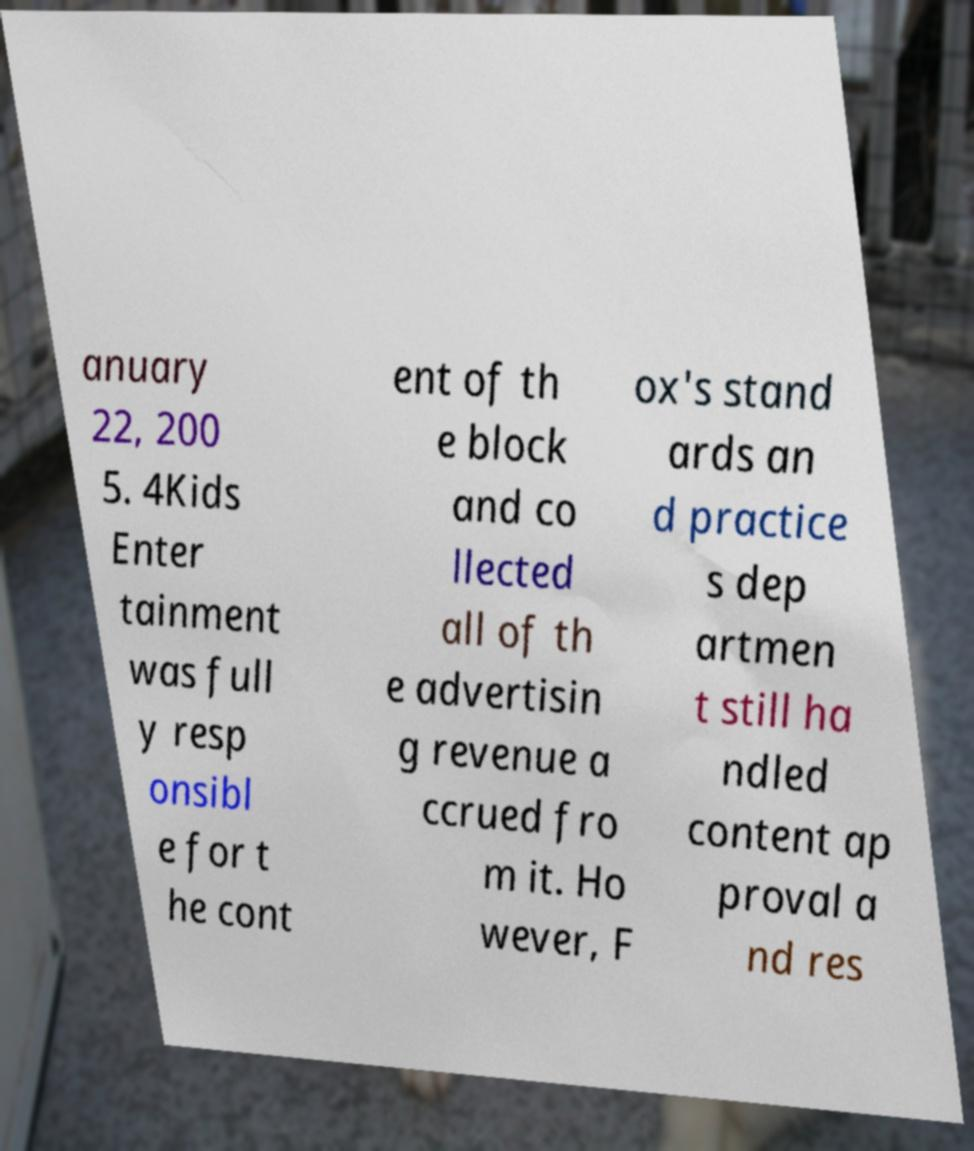There's text embedded in this image that I need extracted. Can you transcribe it verbatim? anuary 22, 200 5. 4Kids Enter tainment was full y resp onsibl e for t he cont ent of th e block and co llected all of th e advertisin g revenue a ccrued fro m it. Ho wever, F ox's stand ards an d practice s dep artmen t still ha ndled content ap proval a nd res 